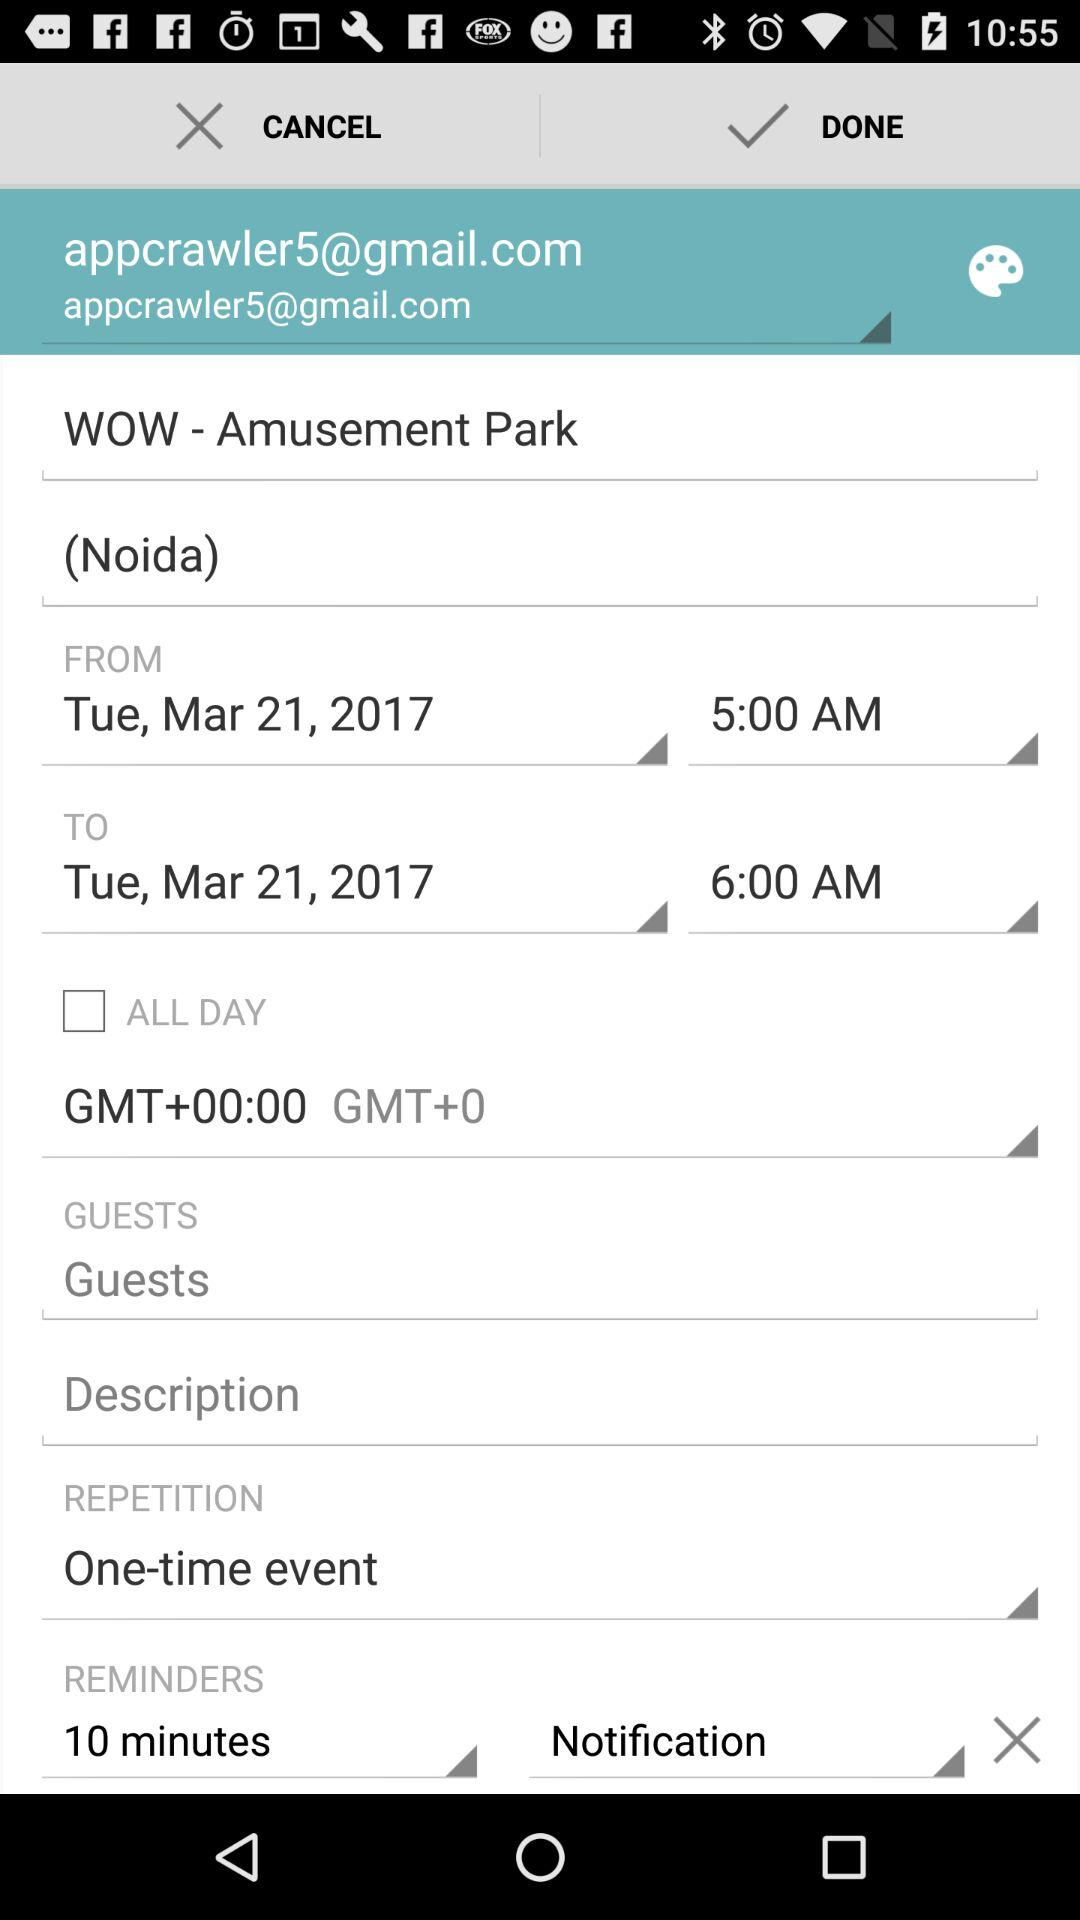What's the "REMINDERS" duration? The duration is 10 minutes. 